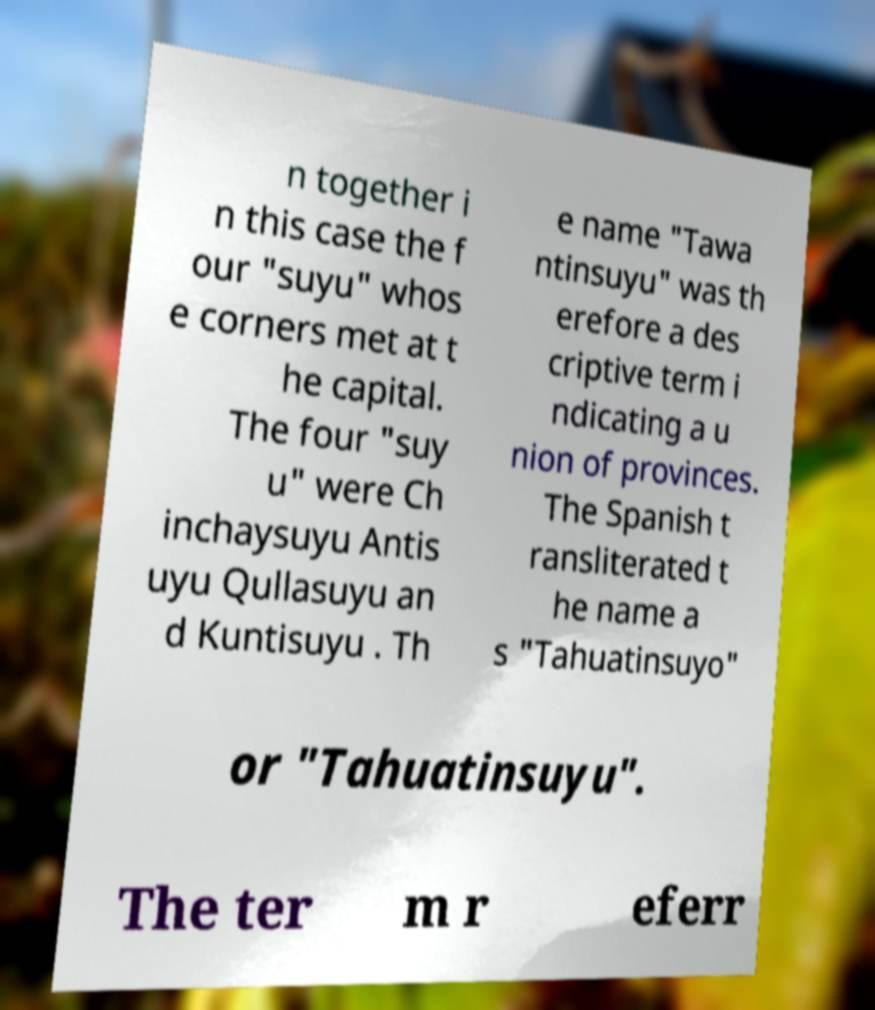I need the written content from this picture converted into text. Can you do that? n together i n this case the f our "suyu" whos e corners met at t he capital. The four "suy u" were Ch inchaysuyu Antis uyu Qullasuyu an d Kuntisuyu . Th e name "Tawa ntinsuyu" was th erefore a des criptive term i ndicating a u nion of provinces. The Spanish t ransliterated t he name a s "Tahuatinsuyo" or "Tahuatinsuyu". The ter m r eferr 